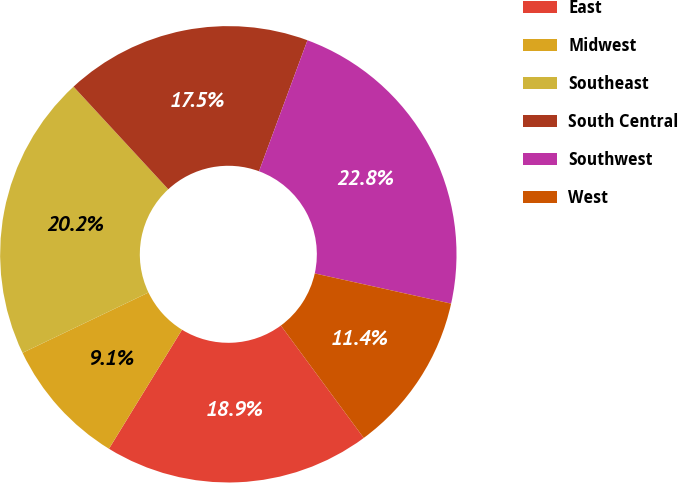<chart> <loc_0><loc_0><loc_500><loc_500><pie_chart><fcel>East<fcel>Midwest<fcel>Southeast<fcel>South Central<fcel>Southwest<fcel>West<nl><fcel>18.87%<fcel>9.13%<fcel>20.24%<fcel>17.5%<fcel>22.83%<fcel>11.42%<nl></chart> 